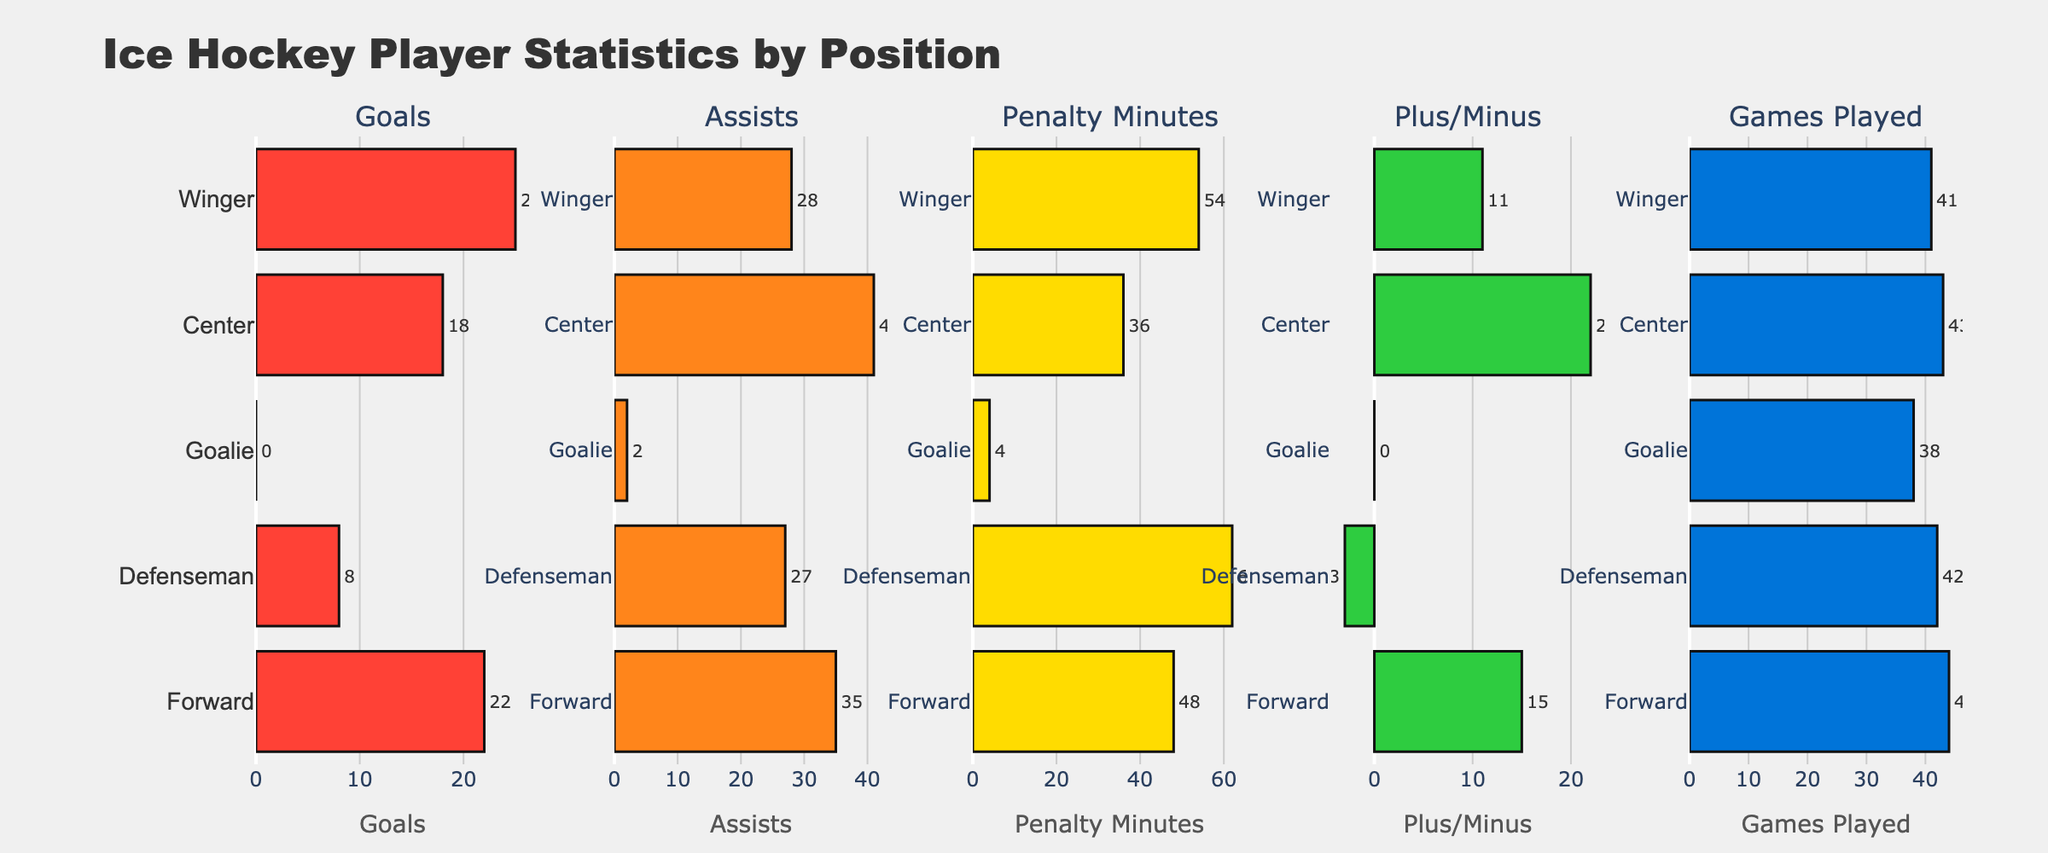What's the title of the figure? The title of the figure is located at the top center and is the largest text in the plot. It reads "Tattoo Style Popularity Trends at Old Soul Tattoo".
Answer: Tattoo Style Popularity Trends at Old Soul Tattoo How many tattoo styles are compared in the figure? Each subplot represents a tattoo style, and there are five subplots. Therefore, five tattoo styles are compared.
Answer: Five Which tattoo style showed the highest popularity increase from 2013 to 2023? By looking at the starting and ending values of each line in the subplots, the "Minimalist" style increased the most, from 5% in 2013 to 30% in 2023.
Answer: Minimalist In which year did the "Traditional" style have the highest popularity? In the subplot for "Traditional," the highest point on the y-axis (35%) is in 2013.
Answer: 2013 What is the range of popularity percentages shown on the y-axis for each tattoo style? Each subplot's y-axis ranges from 0% to 45%, according to the y-axis labels on the sides of the subplots.
Answer: 0% to 45% Which tattoo style had a decreasing trend in popularity over the decade? By observing each subplot, the "Traditional" tattoo style shows a consistent downward trend from 35% in 2013 to 10% in 2023.
Answer: Traditional What is the popularity of "Watercolor" tattoos in 2019? Looking at the data point for the year 2019 in the "Watercolor" subplot, the value is 25%.
Answer: 25% What was the difference in popularity between "Geometric" and "Neo-Traditional" styles in 2023? For 2023, "Geometric" has a popularity of 40%, and "Neo-Traditional" has 25%. The difference is 40% - 25% = 15%.
Answer: 15% Between which years did "Geometric" tattoos show the highest rate of increase? By comparing the slopes of the lines between each year for "Geometric," the steepest line appears between 2017 (25%) and 2019 (30%), indicating the highest rate of increase (5%).
Answer: 2017 to 2019 Which style had the second highest popularity in 2021? For 2021, "Geometric" (35%) is the most popular, followed by "Watercolor" (30%), which is second highest.
Answer: Watercolor 